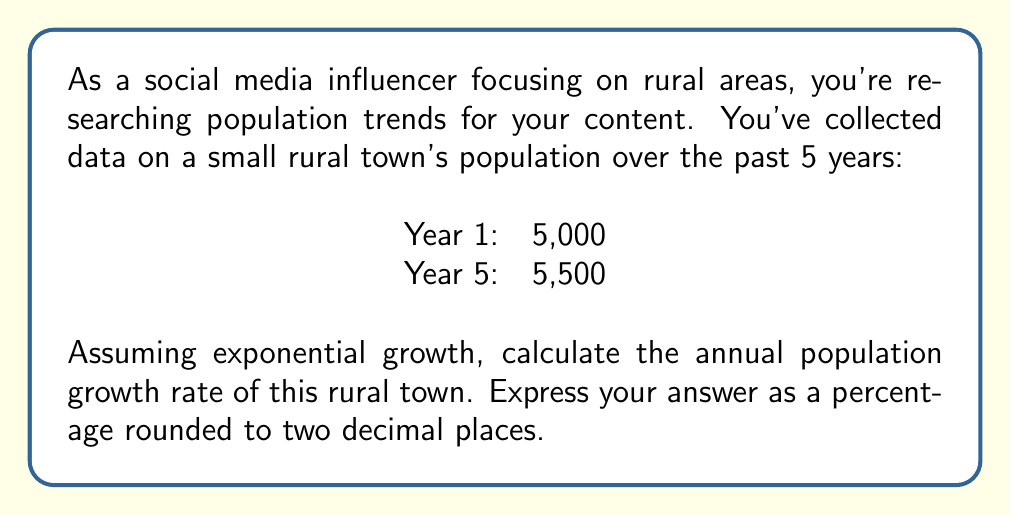Solve this math problem. To solve this problem, we'll use the exponential growth formula:

$$A = P(1 + r)^t$$

Where:
$A$ = Final amount (population after 5 years)
$P$ = Initial amount (initial population)
$r$ = Annual growth rate (in decimal form)
$t$ = Time period (in years)

Given:
$A = 5,500$
$P = 5,000$
$t = 5$ years

Step 1: Plug the known values into the formula
$$5,500 = 5,000(1 + r)^5$$

Step 2: Divide both sides by 5,000
$$\frac{5,500}{5,000} = (1 + r)^5$$

Step 3: Simplify
$$1.1 = (1 + r)^5$$

Step 4: Take the 5th root of both sides
$$\sqrt[5]{1.1} = 1 + r$$

Step 5: Subtract 1 from both sides
$$\sqrt[5]{1.1} - 1 = r$$

Step 6: Calculate the value of $r$
$$r \approx 0.0193$$

Step 7: Convert to a percentage by multiplying by 100
$$0.0193 * 100 \approx 1.93\%$$

Therefore, the annual population growth rate is approximately 1.93%.
Answer: 1.93% 